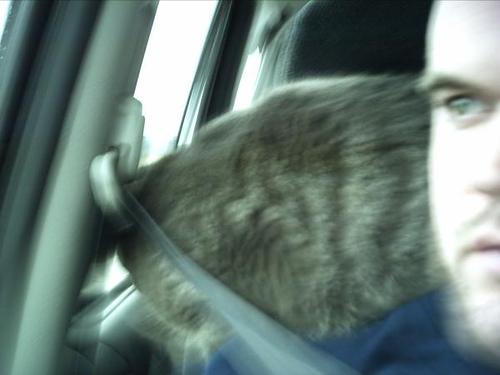What is behind this man?
Answer briefly. Cat. Is the man looking out the window?
Answer briefly. Yes. Is the photo clear?
Give a very brief answer. No. 